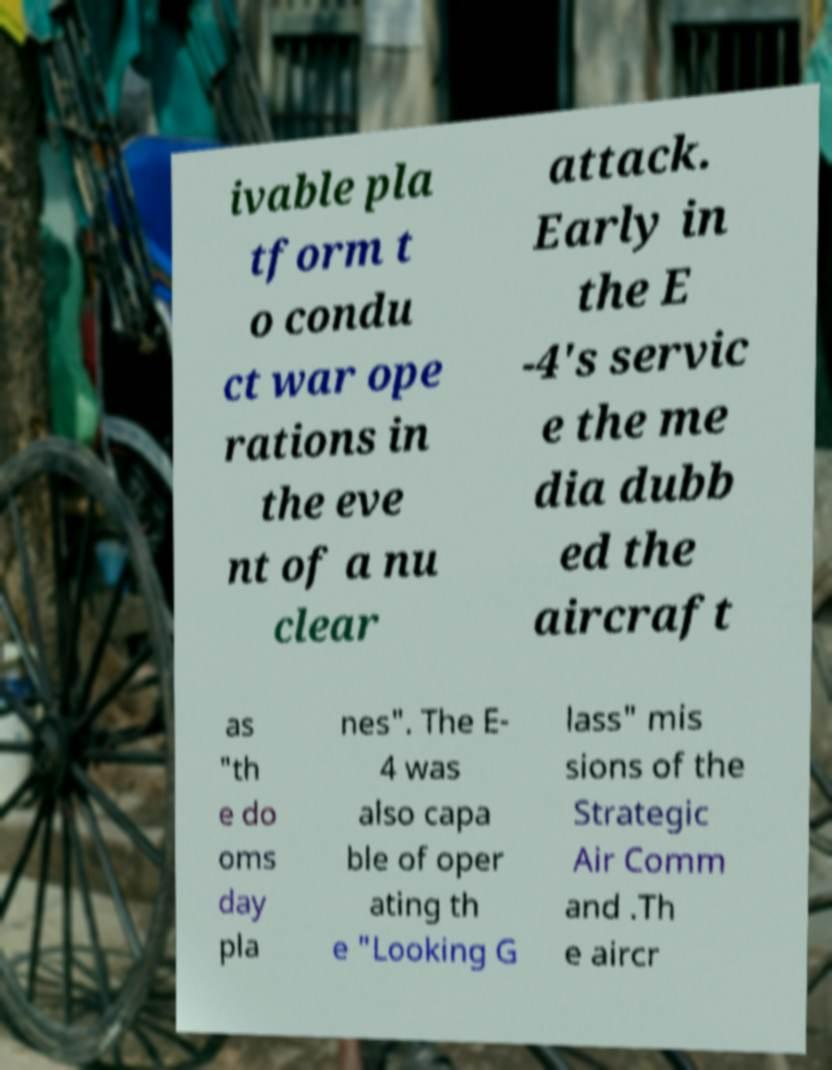Could you extract and type out the text from this image? ivable pla tform t o condu ct war ope rations in the eve nt of a nu clear attack. Early in the E -4's servic e the me dia dubb ed the aircraft as "th e do oms day pla nes". The E- 4 was also capa ble of oper ating th e "Looking G lass" mis sions of the Strategic Air Comm and .Th e aircr 